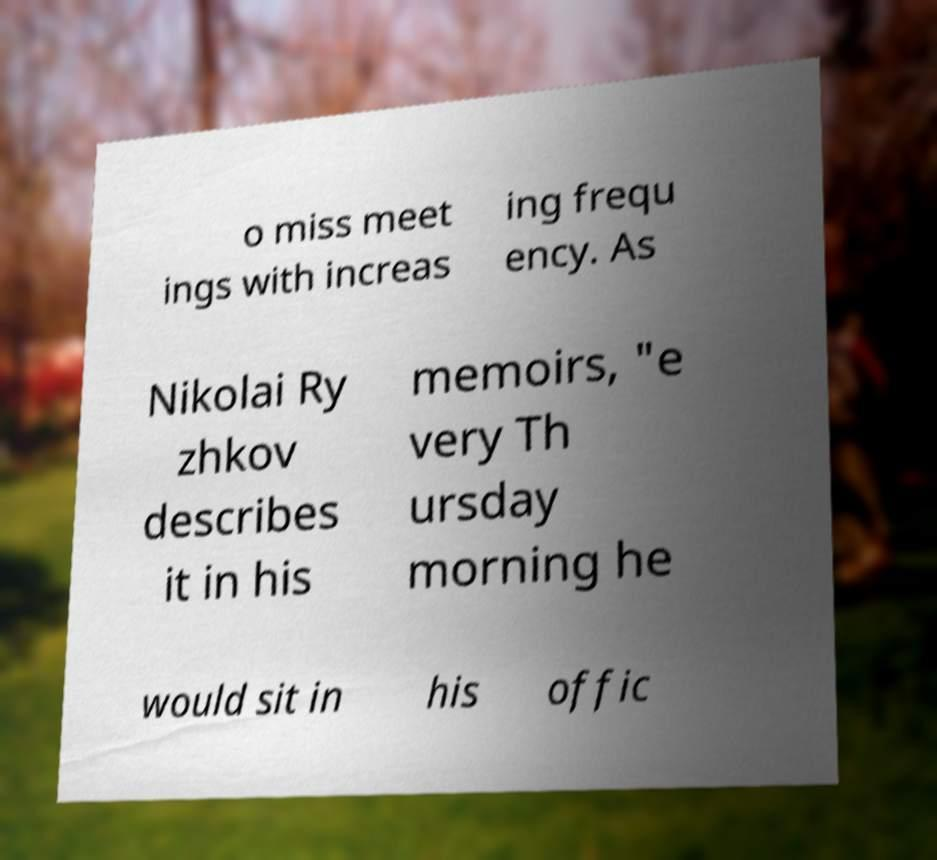Could you assist in decoding the text presented in this image and type it out clearly? o miss meet ings with increas ing frequ ency. As Nikolai Ry zhkov describes it in his memoirs, "e very Th ursday morning he would sit in his offic 